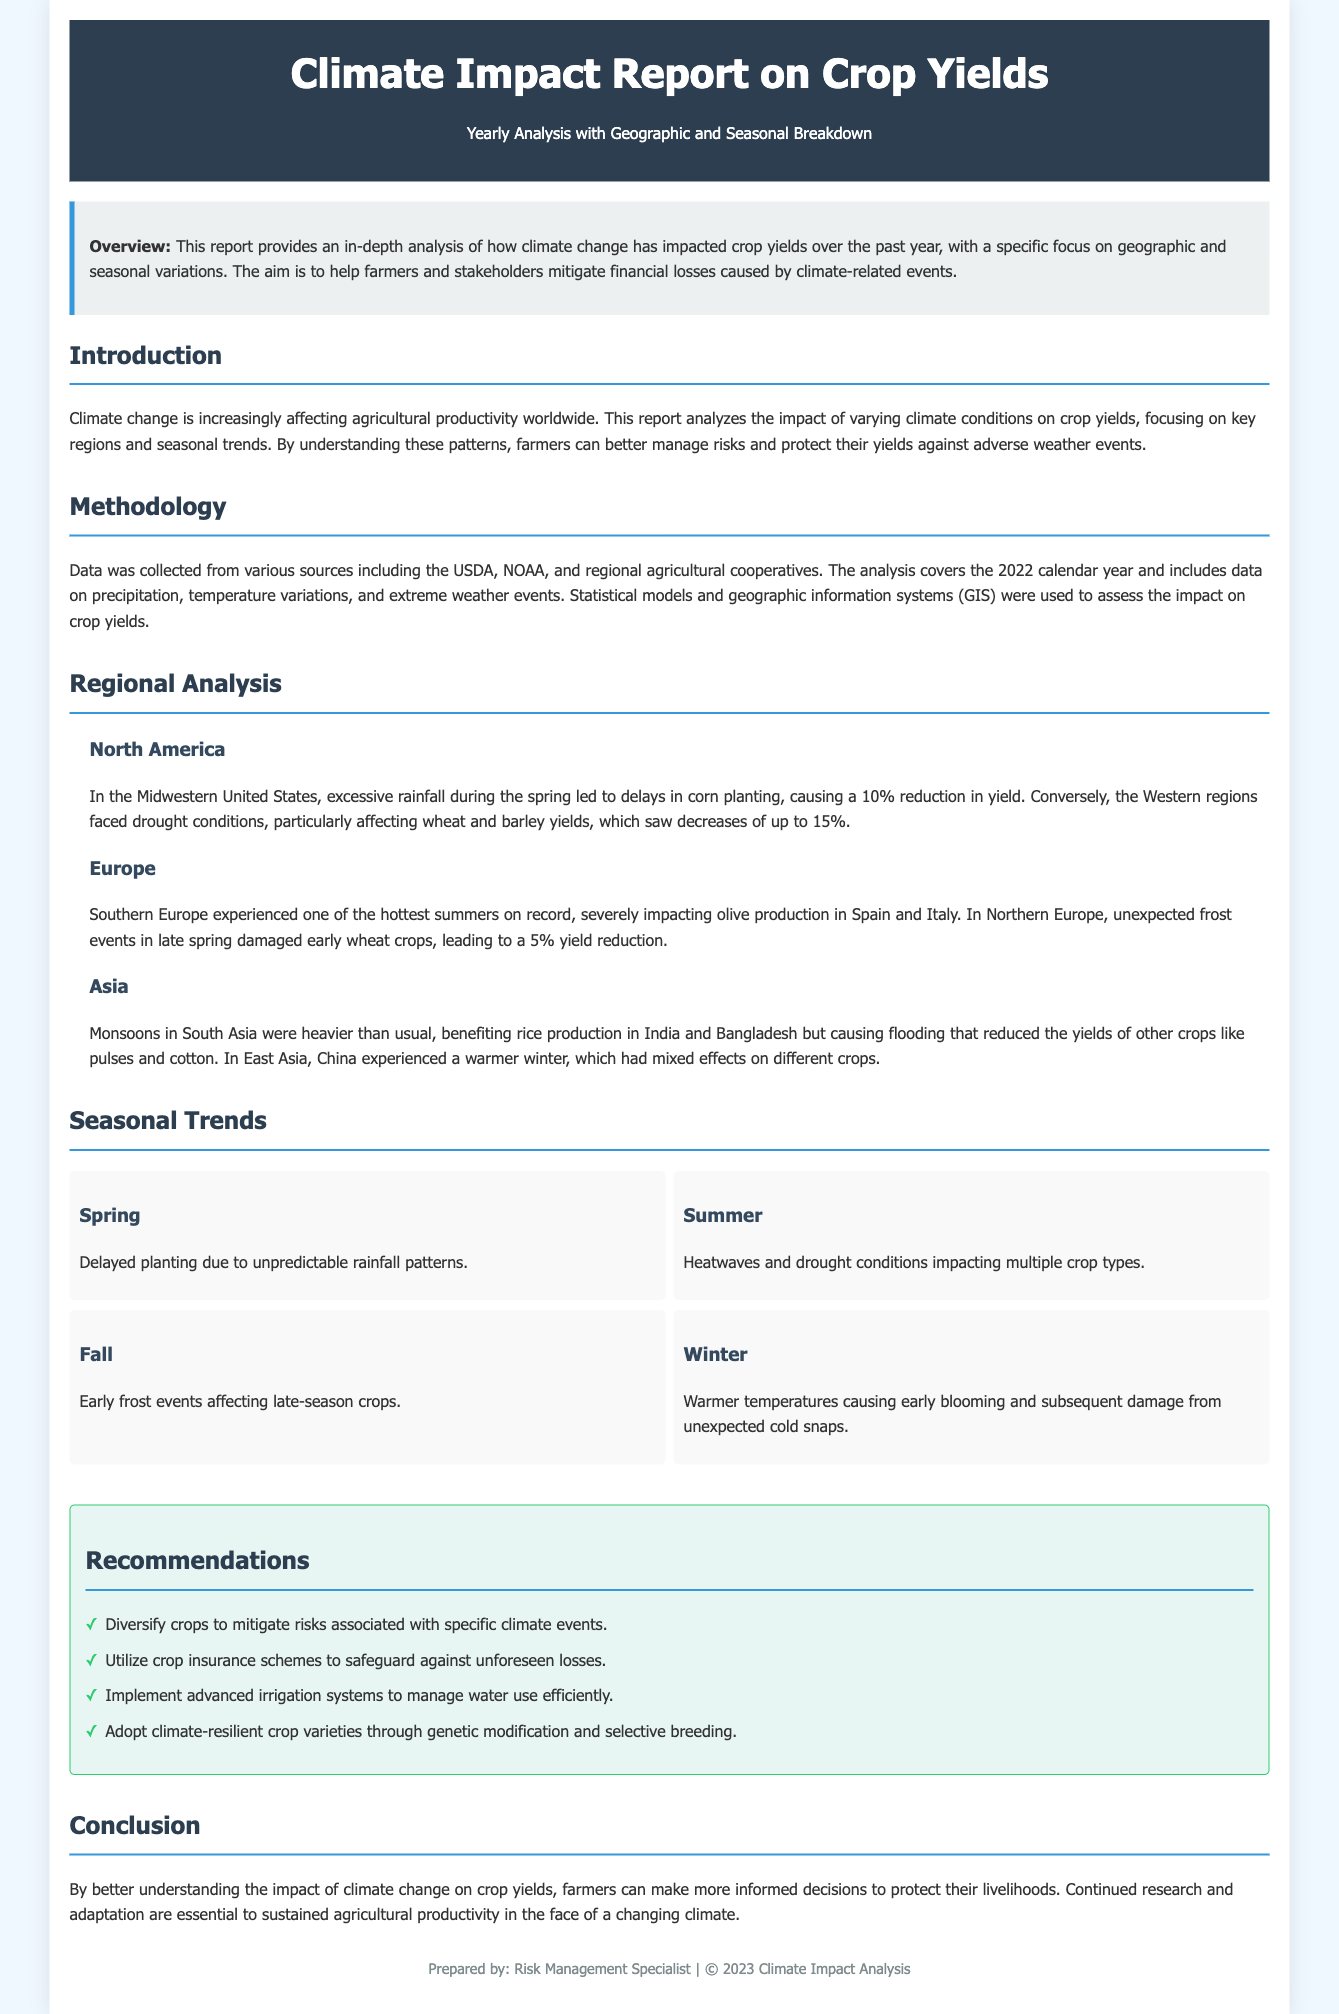What is the title of the report? The title of the report is stated clearly at the beginning of the document.
Answer: Climate Impact Report on Crop Yields What is the main focus of the report? The main focus is outlined in the overview section, summarizing the report’s aim and approach.
Answer: Geographic and seasonal variations What percentage reduction in corn yield was caused by excessive rainfall in the Midwestern United States? This information can be gathered from the regional analysis section under North America.
Answer: 10% Which season experienced delays in planting due to unpredictable rainfall? This information is found in the seasonal trends section relating to planting delays.
Answer: Spring What is one recommended strategy to mitigate climate-related risks? Recommendations provide specific strategies for farmers to protect their yields.
Answer: Diversify crops Which region faced drought conditions impacting wheat and barley yields? Regional analysis highlights specific challenges in different geographic areas.
Answer: Western regions What was the impact of late spring frost on crops in Northern Europe? This detail is noted under the regional analysis for Europe, focusing on frost events.
Answer: 5% yield reduction What type of data was collected for the analysis? The methodology section outlines the sources of information relevant to the report.
Answer: USDA, NOAA, regional agricultural cooperatives How did warmer temperatures in winter influence blooming? The seasonal trends section indicates specific effects of climate conditions on blooming.
Answer: Early blooming and damage from cold snaps 